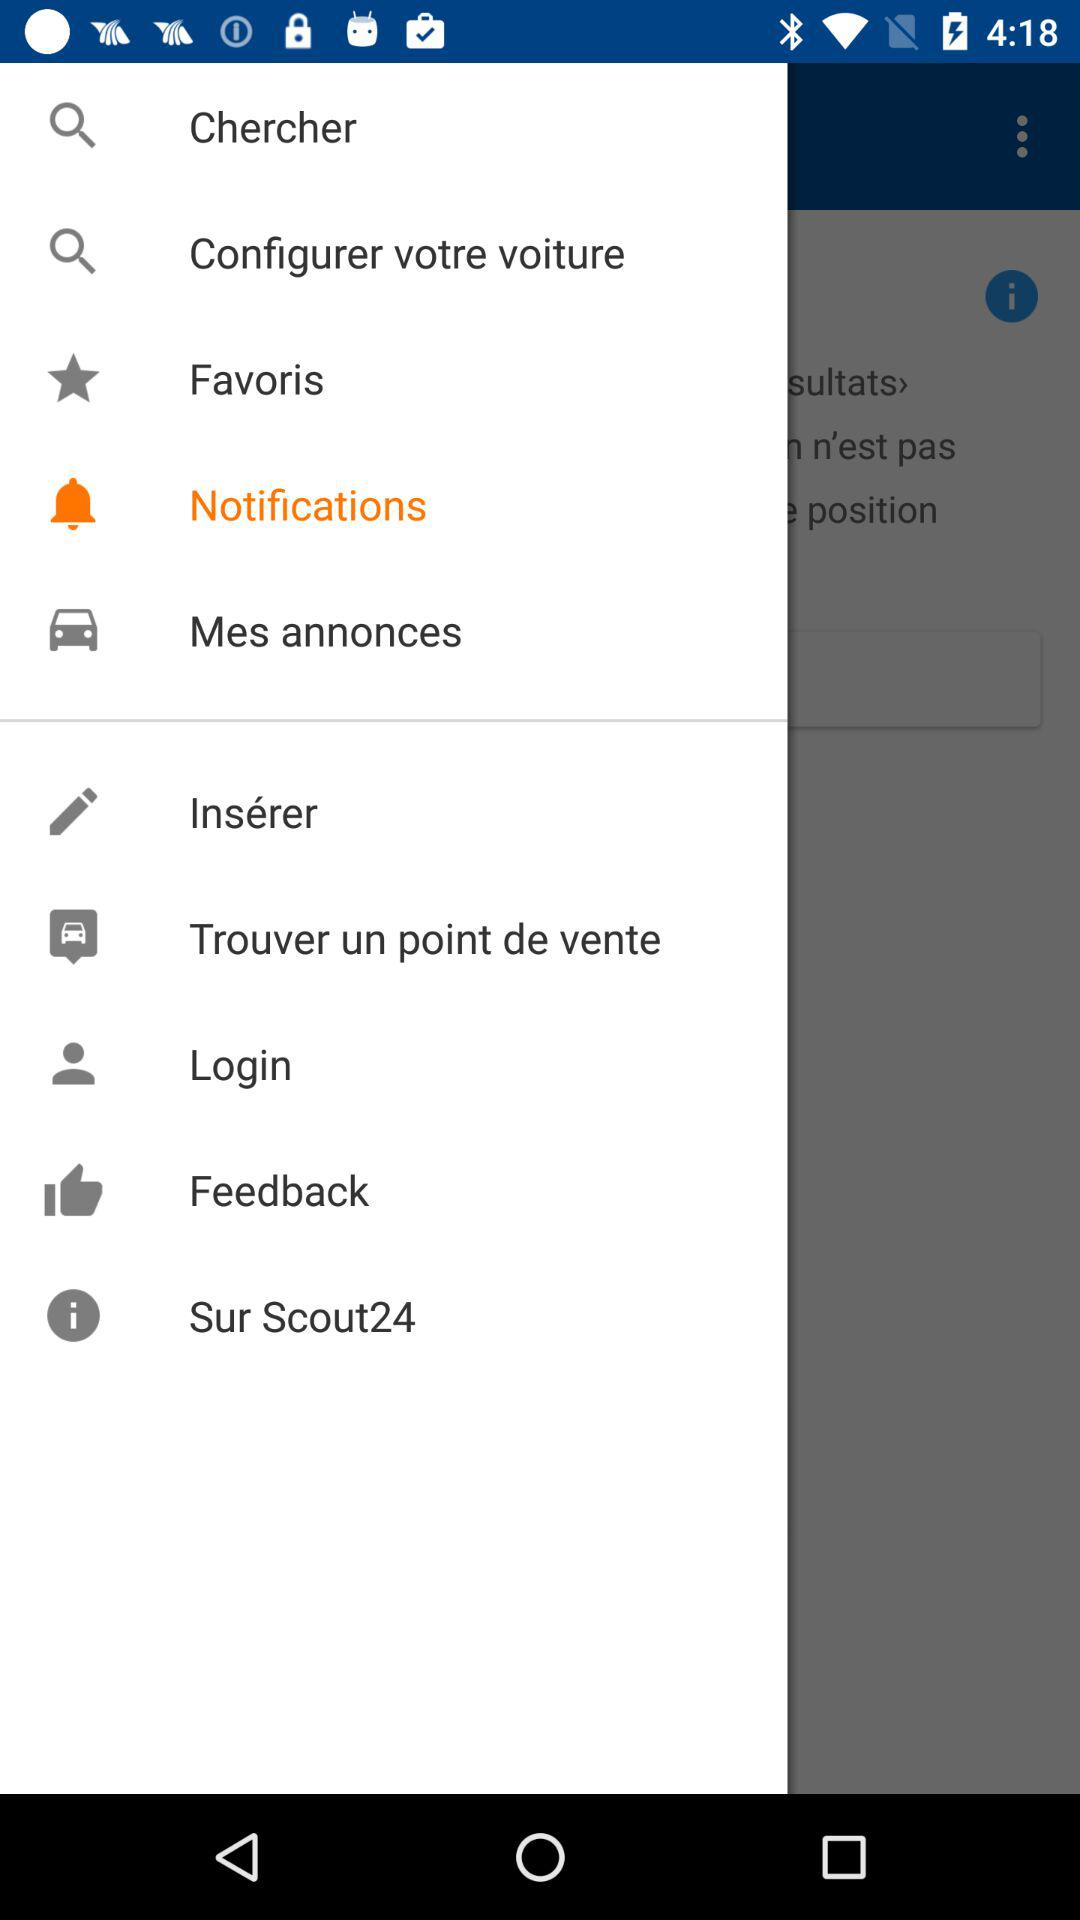What option has been selected? The selected option is notifications. 